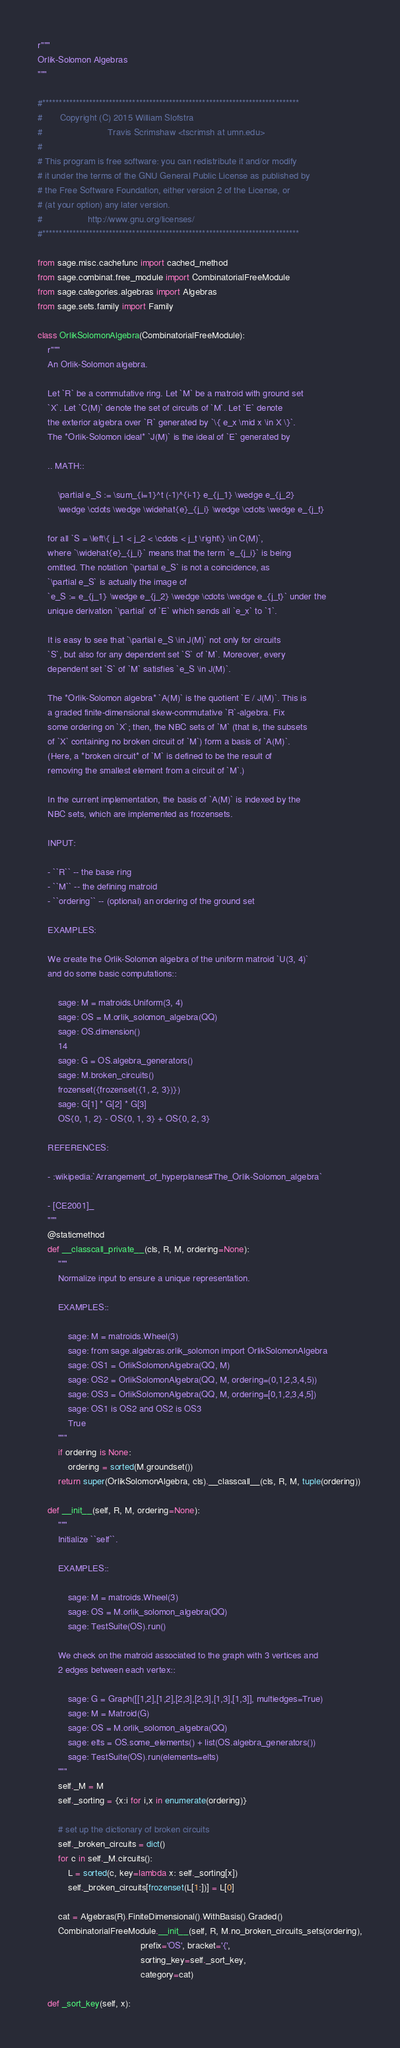Convert code to text. <code><loc_0><loc_0><loc_500><loc_500><_Python_>r"""
Orlik-Solomon Algebras
"""

#*****************************************************************************
#       Copyright (C) 2015 William Slofstra
#                          Travis Scrimshaw <tscrimsh at umn.edu>
#
# This program is free software: you can redistribute it and/or modify
# it under the terms of the GNU General Public License as published by
# the Free Software Foundation, either version 2 of the License, or
# (at your option) any later version.
#                  http://www.gnu.org/licenses/
#*****************************************************************************

from sage.misc.cachefunc import cached_method
from sage.combinat.free_module import CombinatorialFreeModule
from sage.categories.algebras import Algebras
from sage.sets.family import Family

class OrlikSolomonAlgebra(CombinatorialFreeModule):
    r"""
    An Orlik-Solomon algebra.

    Let `R` be a commutative ring. Let `M` be a matroid with ground set
    `X`. Let `C(M)` denote the set of circuits of `M`. Let `E` denote
    the exterior algebra over `R` generated by `\{ e_x \mid x \in X \}`.
    The *Orlik-Solomon ideal* `J(M)` is the ideal of `E` generated by

    .. MATH::

        \partial e_S := \sum_{i=1}^t (-1)^{i-1} e_{j_1} \wedge e_{j_2}
        \wedge \cdots \wedge \widehat{e}_{j_i} \wedge \cdots \wedge e_{j_t}

    for all `S = \left\{ j_1 < j_2 < \cdots < j_t \right\} \in C(M)`,
    where `\widehat{e}_{j_i}` means that the term `e_{j_i}` is being
    omitted. The notation `\partial e_S` is not a coincidence, as
    `\partial e_S` is actually the image of
    `e_S := e_{j_1} \wedge e_{j_2} \wedge \cdots \wedge e_{j_t}` under the
    unique derivation `\partial` of `E` which sends all `e_x` to `1`.

    It is easy to see that `\partial e_S \in J(M)` not only for circuits
    `S`, but also for any dependent set `S` of `M`. Moreover, every
    dependent set `S` of `M` satisfies `e_S \in J(M)`.

    The *Orlik-Solomon algebra* `A(M)` is the quotient `E / J(M)`. This is
    a graded finite-dimensional skew-commutative `R`-algebra. Fix
    some ordering on `X`; then, the NBC sets of `M` (that is, the subsets
    of `X` containing no broken circuit of `M`) form a basis of `A(M)`.
    (Here, a *broken circuit* of `M` is defined to be the result of
    removing the smallest element from a circuit of `M`.)

    In the current implementation, the basis of `A(M)` is indexed by the
    NBC sets, which are implemented as frozensets.

    INPUT:

    - ``R`` -- the base ring
    - ``M`` -- the defining matroid
    - ``ordering`` -- (optional) an ordering of the ground set

    EXAMPLES:

    We create the Orlik-Solomon algebra of the uniform matroid `U(3, 4)`
    and do some basic computations::

        sage: M = matroids.Uniform(3, 4)
        sage: OS = M.orlik_solomon_algebra(QQ)
        sage: OS.dimension()
        14
        sage: G = OS.algebra_generators()
        sage: M.broken_circuits()
        frozenset({frozenset({1, 2, 3})})
        sage: G[1] * G[2] * G[3]
        OS{0, 1, 2} - OS{0, 1, 3} + OS{0, 2, 3}

    REFERENCES:

    - :wikipedia:`Arrangement_of_hyperplanes#The_Orlik-Solomon_algebra`

    - [CE2001]_
    """
    @staticmethod
    def __classcall_private__(cls, R, M, ordering=None):
        """
        Normalize input to ensure a unique representation.

        EXAMPLES::

            sage: M = matroids.Wheel(3)
            sage: from sage.algebras.orlik_solomon import OrlikSolomonAlgebra
            sage: OS1 = OrlikSolomonAlgebra(QQ, M)
            sage: OS2 = OrlikSolomonAlgebra(QQ, M, ordering=(0,1,2,3,4,5))
            sage: OS3 = OrlikSolomonAlgebra(QQ, M, ordering=[0,1,2,3,4,5])
            sage: OS1 is OS2 and OS2 is OS3
            True
        """
        if ordering is None:
            ordering = sorted(M.groundset())
        return super(OrlikSolomonAlgebra, cls).__classcall__(cls, R, M, tuple(ordering))

    def __init__(self, R, M, ordering=None):
        """
        Initialize ``self``.

        EXAMPLES::

            sage: M = matroids.Wheel(3)
            sage: OS = M.orlik_solomon_algebra(QQ)
            sage: TestSuite(OS).run()

        We check on the matroid associated to the graph with 3 vertices and
        2 edges between each vertex::

            sage: G = Graph([[1,2],[1,2],[2,3],[2,3],[1,3],[1,3]], multiedges=True)
            sage: M = Matroid(G)
            sage: OS = M.orlik_solomon_algebra(QQ)
            sage: elts = OS.some_elements() + list(OS.algebra_generators())
            sage: TestSuite(OS).run(elements=elts)
        """
        self._M = M
        self._sorting = {x:i for i,x in enumerate(ordering)}

        # set up the dictionary of broken circuits
        self._broken_circuits = dict()
        for c in self._M.circuits():
            L = sorted(c, key=lambda x: self._sorting[x])
            self._broken_circuits[frozenset(L[1:])] = L[0]

        cat = Algebras(R).FiniteDimensional().WithBasis().Graded()
        CombinatorialFreeModule.__init__(self, R, M.no_broken_circuits_sets(ordering),
                                         prefix='OS', bracket='{',
                                         sorting_key=self._sort_key,
                                         category=cat)

    def _sort_key(self, x):</code> 